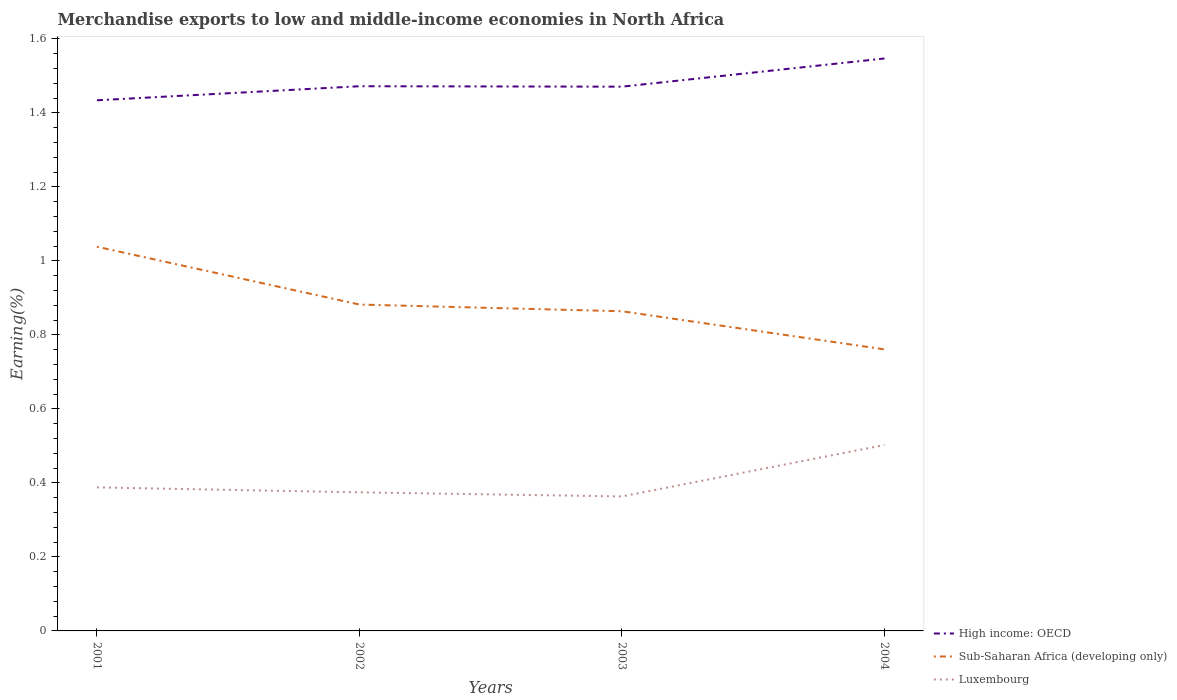How many different coloured lines are there?
Ensure brevity in your answer.  3. Across all years, what is the maximum percentage of amount earned from merchandise exports in Luxembourg?
Offer a very short reply. 0.36. What is the total percentage of amount earned from merchandise exports in High income: OECD in the graph?
Keep it short and to the point. -0.04. What is the difference between the highest and the second highest percentage of amount earned from merchandise exports in Luxembourg?
Give a very brief answer. 0.14. What is the difference between the highest and the lowest percentage of amount earned from merchandise exports in Sub-Saharan Africa (developing only)?
Your answer should be compact. 1. How many lines are there?
Provide a succinct answer. 3. What is the difference between two consecutive major ticks on the Y-axis?
Your answer should be compact. 0.2. Does the graph contain grids?
Offer a very short reply. No. Where does the legend appear in the graph?
Ensure brevity in your answer.  Bottom right. What is the title of the graph?
Offer a terse response. Merchandise exports to low and middle-income economies in North Africa. What is the label or title of the X-axis?
Keep it short and to the point. Years. What is the label or title of the Y-axis?
Offer a very short reply. Earning(%). What is the Earning(%) in High income: OECD in 2001?
Your answer should be compact. 1.43. What is the Earning(%) in Sub-Saharan Africa (developing only) in 2001?
Provide a succinct answer. 1.04. What is the Earning(%) of Luxembourg in 2001?
Provide a short and direct response. 0.39. What is the Earning(%) of High income: OECD in 2002?
Give a very brief answer. 1.47. What is the Earning(%) of Sub-Saharan Africa (developing only) in 2002?
Offer a terse response. 0.88. What is the Earning(%) of Luxembourg in 2002?
Your answer should be compact. 0.37. What is the Earning(%) of High income: OECD in 2003?
Offer a terse response. 1.47. What is the Earning(%) of Sub-Saharan Africa (developing only) in 2003?
Provide a short and direct response. 0.86. What is the Earning(%) in Luxembourg in 2003?
Your answer should be compact. 0.36. What is the Earning(%) in High income: OECD in 2004?
Ensure brevity in your answer.  1.55. What is the Earning(%) in Sub-Saharan Africa (developing only) in 2004?
Offer a very short reply. 0.76. What is the Earning(%) of Luxembourg in 2004?
Provide a short and direct response. 0.5. Across all years, what is the maximum Earning(%) of High income: OECD?
Your answer should be very brief. 1.55. Across all years, what is the maximum Earning(%) of Sub-Saharan Africa (developing only)?
Offer a very short reply. 1.04. Across all years, what is the maximum Earning(%) in Luxembourg?
Your answer should be very brief. 0.5. Across all years, what is the minimum Earning(%) of High income: OECD?
Make the answer very short. 1.43. Across all years, what is the minimum Earning(%) in Sub-Saharan Africa (developing only)?
Make the answer very short. 0.76. Across all years, what is the minimum Earning(%) of Luxembourg?
Your response must be concise. 0.36. What is the total Earning(%) in High income: OECD in the graph?
Provide a succinct answer. 5.92. What is the total Earning(%) in Sub-Saharan Africa (developing only) in the graph?
Provide a succinct answer. 3.55. What is the total Earning(%) in Luxembourg in the graph?
Offer a very short reply. 1.63. What is the difference between the Earning(%) of High income: OECD in 2001 and that in 2002?
Give a very brief answer. -0.04. What is the difference between the Earning(%) of Sub-Saharan Africa (developing only) in 2001 and that in 2002?
Keep it short and to the point. 0.16. What is the difference between the Earning(%) in Luxembourg in 2001 and that in 2002?
Give a very brief answer. 0.01. What is the difference between the Earning(%) in High income: OECD in 2001 and that in 2003?
Provide a short and direct response. -0.04. What is the difference between the Earning(%) of Sub-Saharan Africa (developing only) in 2001 and that in 2003?
Offer a terse response. 0.17. What is the difference between the Earning(%) in Luxembourg in 2001 and that in 2003?
Make the answer very short. 0.02. What is the difference between the Earning(%) of High income: OECD in 2001 and that in 2004?
Your response must be concise. -0.11. What is the difference between the Earning(%) in Sub-Saharan Africa (developing only) in 2001 and that in 2004?
Ensure brevity in your answer.  0.28. What is the difference between the Earning(%) of Luxembourg in 2001 and that in 2004?
Make the answer very short. -0.11. What is the difference between the Earning(%) of High income: OECD in 2002 and that in 2003?
Provide a short and direct response. 0. What is the difference between the Earning(%) in Sub-Saharan Africa (developing only) in 2002 and that in 2003?
Your answer should be compact. 0.02. What is the difference between the Earning(%) of Luxembourg in 2002 and that in 2003?
Provide a short and direct response. 0.01. What is the difference between the Earning(%) of High income: OECD in 2002 and that in 2004?
Your answer should be compact. -0.07. What is the difference between the Earning(%) of Sub-Saharan Africa (developing only) in 2002 and that in 2004?
Your response must be concise. 0.12. What is the difference between the Earning(%) in Luxembourg in 2002 and that in 2004?
Give a very brief answer. -0.13. What is the difference between the Earning(%) in High income: OECD in 2003 and that in 2004?
Your answer should be compact. -0.08. What is the difference between the Earning(%) of Sub-Saharan Africa (developing only) in 2003 and that in 2004?
Give a very brief answer. 0.1. What is the difference between the Earning(%) of Luxembourg in 2003 and that in 2004?
Make the answer very short. -0.14. What is the difference between the Earning(%) in High income: OECD in 2001 and the Earning(%) in Sub-Saharan Africa (developing only) in 2002?
Offer a very short reply. 0.55. What is the difference between the Earning(%) of High income: OECD in 2001 and the Earning(%) of Luxembourg in 2002?
Ensure brevity in your answer.  1.06. What is the difference between the Earning(%) of Sub-Saharan Africa (developing only) in 2001 and the Earning(%) of Luxembourg in 2002?
Ensure brevity in your answer.  0.66. What is the difference between the Earning(%) of High income: OECD in 2001 and the Earning(%) of Sub-Saharan Africa (developing only) in 2003?
Offer a very short reply. 0.57. What is the difference between the Earning(%) of High income: OECD in 2001 and the Earning(%) of Luxembourg in 2003?
Offer a very short reply. 1.07. What is the difference between the Earning(%) of Sub-Saharan Africa (developing only) in 2001 and the Earning(%) of Luxembourg in 2003?
Keep it short and to the point. 0.67. What is the difference between the Earning(%) in High income: OECD in 2001 and the Earning(%) in Sub-Saharan Africa (developing only) in 2004?
Provide a succinct answer. 0.67. What is the difference between the Earning(%) of High income: OECD in 2001 and the Earning(%) of Luxembourg in 2004?
Give a very brief answer. 0.93. What is the difference between the Earning(%) of Sub-Saharan Africa (developing only) in 2001 and the Earning(%) of Luxembourg in 2004?
Ensure brevity in your answer.  0.54. What is the difference between the Earning(%) in High income: OECD in 2002 and the Earning(%) in Sub-Saharan Africa (developing only) in 2003?
Offer a very short reply. 0.61. What is the difference between the Earning(%) in High income: OECD in 2002 and the Earning(%) in Luxembourg in 2003?
Give a very brief answer. 1.11. What is the difference between the Earning(%) in Sub-Saharan Africa (developing only) in 2002 and the Earning(%) in Luxembourg in 2003?
Make the answer very short. 0.52. What is the difference between the Earning(%) of High income: OECD in 2002 and the Earning(%) of Sub-Saharan Africa (developing only) in 2004?
Your response must be concise. 0.71. What is the difference between the Earning(%) of High income: OECD in 2002 and the Earning(%) of Luxembourg in 2004?
Your answer should be very brief. 0.97. What is the difference between the Earning(%) of Sub-Saharan Africa (developing only) in 2002 and the Earning(%) of Luxembourg in 2004?
Give a very brief answer. 0.38. What is the difference between the Earning(%) in High income: OECD in 2003 and the Earning(%) in Sub-Saharan Africa (developing only) in 2004?
Offer a very short reply. 0.71. What is the difference between the Earning(%) in High income: OECD in 2003 and the Earning(%) in Luxembourg in 2004?
Your response must be concise. 0.97. What is the difference between the Earning(%) in Sub-Saharan Africa (developing only) in 2003 and the Earning(%) in Luxembourg in 2004?
Your answer should be very brief. 0.36. What is the average Earning(%) in High income: OECD per year?
Your response must be concise. 1.48. What is the average Earning(%) of Sub-Saharan Africa (developing only) per year?
Your answer should be compact. 0.89. What is the average Earning(%) in Luxembourg per year?
Give a very brief answer. 0.41. In the year 2001, what is the difference between the Earning(%) in High income: OECD and Earning(%) in Sub-Saharan Africa (developing only)?
Your answer should be very brief. 0.4. In the year 2001, what is the difference between the Earning(%) of High income: OECD and Earning(%) of Luxembourg?
Offer a very short reply. 1.05. In the year 2001, what is the difference between the Earning(%) in Sub-Saharan Africa (developing only) and Earning(%) in Luxembourg?
Keep it short and to the point. 0.65. In the year 2002, what is the difference between the Earning(%) in High income: OECD and Earning(%) in Sub-Saharan Africa (developing only)?
Your answer should be very brief. 0.59. In the year 2002, what is the difference between the Earning(%) in High income: OECD and Earning(%) in Luxembourg?
Offer a terse response. 1.1. In the year 2002, what is the difference between the Earning(%) in Sub-Saharan Africa (developing only) and Earning(%) in Luxembourg?
Make the answer very short. 0.51. In the year 2003, what is the difference between the Earning(%) in High income: OECD and Earning(%) in Sub-Saharan Africa (developing only)?
Ensure brevity in your answer.  0.61. In the year 2003, what is the difference between the Earning(%) of High income: OECD and Earning(%) of Luxembourg?
Ensure brevity in your answer.  1.11. In the year 2003, what is the difference between the Earning(%) in Sub-Saharan Africa (developing only) and Earning(%) in Luxembourg?
Offer a terse response. 0.5. In the year 2004, what is the difference between the Earning(%) of High income: OECD and Earning(%) of Sub-Saharan Africa (developing only)?
Offer a very short reply. 0.79. In the year 2004, what is the difference between the Earning(%) in High income: OECD and Earning(%) in Luxembourg?
Your answer should be very brief. 1.04. In the year 2004, what is the difference between the Earning(%) of Sub-Saharan Africa (developing only) and Earning(%) of Luxembourg?
Your response must be concise. 0.26. What is the ratio of the Earning(%) of High income: OECD in 2001 to that in 2002?
Offer a very short reply. 0.97. What is the ratio of the Earning(%) of Sub-Saharan Africa (developing only) in 2001 to that in 2002?
Offer a very short reply. 1.18. What is the ratio of the Earning(%) in Luxembourg in 2001 to that in 2002?
Your response must be concise. 1.04. What is the ratio of the Earning(%) in High income: OECD in 2001 to that in 2003?
Make the answer very short. 0.97. What is the ratio of the Earning(%) of Sub-Saharan Africa (developing only) in 2001 to that in 2003?
Your answer should be compact. 1.2. What is the ratio of the Earning(%) of Luxembourg in 2001 to that in 2003?
Your response must be concise. 1.07. What is the ratio of the Earning(%) of High income: OECD in 2001 to that in 2004?
Your response must be concise. 0.93. What is the ratio of the Earning(%) of Sub-Saharan Africa (developing only) in 2001 to that in 2004?
Your response must be concise. 1.36. What is the ratio of the Earning(%) of Luxembourg in 2001 to that in 2004?
Make the answer very short. 0.77. What is the ratio of the Earning(%) of Sub-Saharan Africa (developing only) in 2002 to that in 2003?
Ensure brevity in your answer.  1.02. What is the ratio of the Earning(%) in Luxembourg in 2002 to that in 2003?
Offer a very short reply. 1.03. What is the ratio of the Earning(%) in High income: OECD in 2002 to that in 2004?
Your answer should be compact. 0.95. What is the ratio of the Earning(%) in Sub-Saharan Africa (developing only) in 2002 to that in 2004?
Ensure brevity in your answer.  1.16. What is the ratio of the Earning(%) of Luxembourg in 2002 to that in 2004?
Make the answer very short. 0.75. What is the ratio of the Earning(%) in High income: OECD in 2003 to that in 2004?
Offer a very short reply. 0.95. What is the ratio of the Earning(%) of Sub-Saharan Africa (developing only) in 2003 to that in 2004?
Keep it short and to the point. 1.14. What is the ratio of the Earning(%) in Luxembourg in 2003 to that in 2004?
Provide a short and direct response. 0.72. What is the difference between the highest and the second highest Earning(%) of High income: OECD?
Provide a succinct answer. 0.07. What is the difference between the highest and the second highest Earning(%) of Sub-Saharan Africa (developing only)?
Your answer should be compact. 0.16. What is the difference between the highest and the second highest Earning(%) of Luxembourg?
Provide a succinct answer. 0.11. What is the difference between the highest and the lowest Earning(%) in High income: OECD?
Your response must be concise. 0.11. What is the difference between the highest and the lowest Earning(%) of Sub-Saharan Africa (developing only)?
Your answer should be compact. 0.28. What is the difference between the highest and the lowest Earning(%) in Luxembourg?
Make the answer very short. 0.14. 